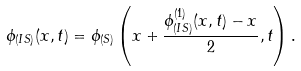<formula> <loc_0><loc_0><loc_500><loc_500>\phi _ { ( I S ) } ( x , t ) = \phi _ { ( S ) } \left ( x + \frac { \phi _ { ( I S ) } ^ { ( 1 ) } ( x , t ) - x } { 2 } , t \right ) .</formula> 